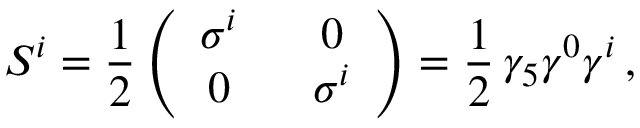<formula> <loc_0><loc_0><loc_500><loc_500>S ^ { i } = { \frac { 1 } { 2 } } \left ( \begin{array} { c c } { { \sigma ^ { i } } } & { 0 } \\ { 0 } & { { \sigma ^ { i } } } \end{array} \right ) = { \frac { 1 } { 2 } } \, \gamma _ { 5 } \gamma ^ { 0 } \gamma ^ { i } \, ,</formula> 